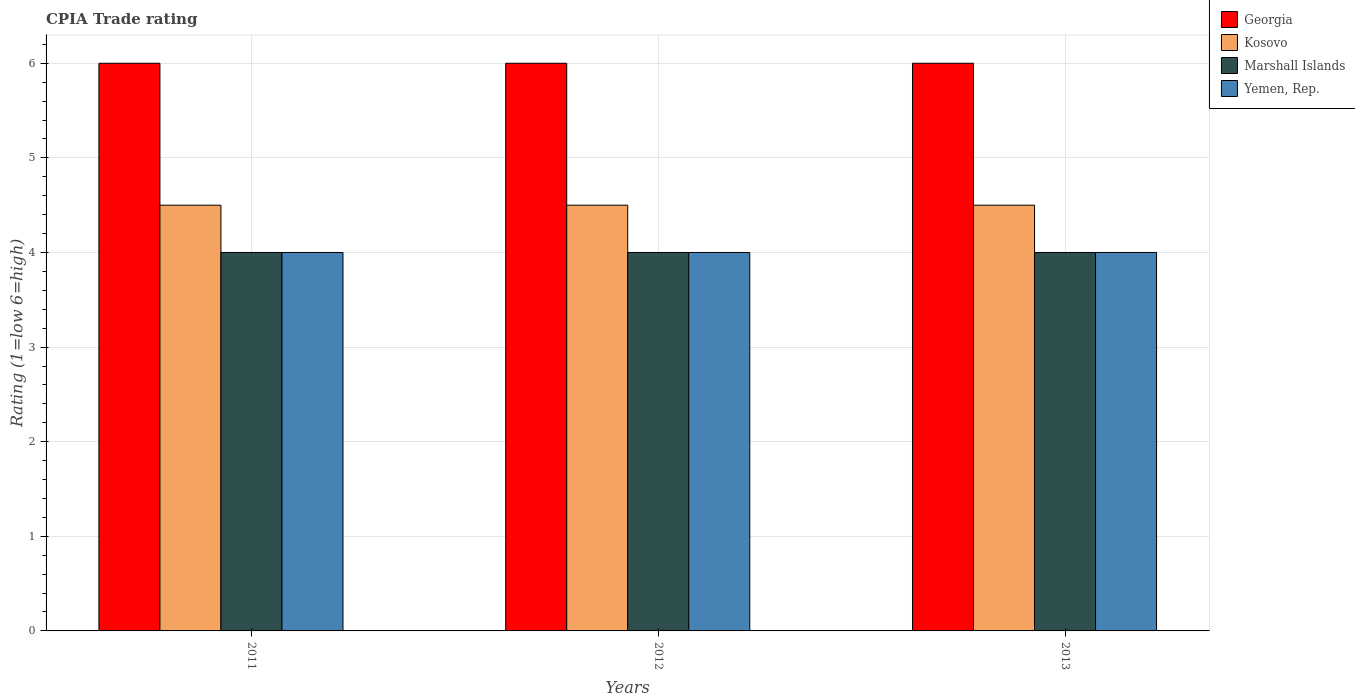Are the number of bars on each tick of the X-axis equal?
Your answer should be compact. Yes. How many bars are there on the 1st tick from the right?
Ensure brevity in your answer.  4. In how many cases, is the number of bars for a given year not equal to the number of legend labels?
Keep it short and to the point. 0. What is the CPIA rating in Marshall Islands in 2013?
Your answer should be compact. 4. Across all years, what is the minimum CPIA rating in Yemen, Rep.?
Your response must be concise. 4. In which year was the CPIA rating in Yemen, Rep. maximum?
Keep it short and to the point. 2011. In which year was the CPIA rating in Marshall Islands minimum?
Your answer should be very brief. 2011. What is the total CPIA rating in Yemen, Rep. in the graph?
Your answer should be compact. 12. In how many years, is the CPIA rating in Marshall Islands greater than 3.6?
Make the answer very short. 3. What is the ratio of the CPIA rating in Yemen, Rep. in 2012 to that in 2013?
Ensure brevity in your answer.  1. In how many years, is the CPIA rating in Georgia greater than the average CPIA rating in Georgia taken over all years?
Make the answer very short. 0. Is the sum of the CPIA rating in Marshall Islands in 2012 and 2013 greater than the maximum CPIA rating in Yemen, Rep. across all years?
Ensure brevity in your answer.  Yes. What does the 1st bar from the left in 2013 represents?
Give a very brief answer. Georgia. What does the 3rd bar from the right in 2011 represents?
Your answer should be very brief. Kosovo. How many bars are there?
Ensure brevity in your answer.  12. Does the graph contain any zero values?
Your response must be concise. No. Where does the legend appear in the graph?
Offer a terse response. Top right. How many legend labels are there?
Your answer should be compact. 4. How are the legend labels stacked?
Your answer should be very brief. Vertical. What is the title of the graph?
Provide a short and direct response. CPIA Trade rating. Does "United Kingdom" appear as one of the legend labels in the graph?
Offer a terse response. No. What is the label or title of the X-axis?
Provide a short and direct response. Years. What is the Rating (1=low 6=high) in Georgia in 2011?
Your response must be concise. 6. What is the Rating (1=low 6=high) of Georgia in 2012?
Ensure brevity in your answer.  6. What is the Rating (1=low 6=high) of Yemen, Rep. in 2012?
Your response must be concise. 4. What is the Rating (1=low 6=high) in Kosovo in 2013?
Ensure brevity in your answer.  4.5. What is the Rating (1=low 6=high) in Yemen, Rep. in 2013?
Provide a succinct answer. 4. Across all years, what is the maximum Rating (1=low 6=high) in Kosovo?
Provide a succinct answer. 4.5. Across all years, what is the minimum Rating (1=low 6=high) of Kosovo?
Offer a terse response. 4.5. Across all years, what is the minimum Rating (1=low 6=high) in Marshall Islands?
Give a very brief answer. 4. What is the difference between the Rating (1=low 6=high) in Georgia in 2011 and that in 2012?
Your response must be concise. 0. What is the difference between the Rating (1=low 6=high) of Kosovo in 2011 and that in 2013?
Keep it short and to the point. 0. What is the difference between the Rating (1=low 6=high) of Marshall Islands in 2011 and that in 2013?
Make the answer very short. 0. What is the difference between the Rating (1=low 6=high) of Kosovo in 2012 and that in 2013?
Provide a short and direct response. 0. What is the difference between the Rating (1=low 6=high) in Marshall Islands in 2012 and that in 2013?
Make the answer very short. 0. What is the difference between the Rating (1=low 6=high) in Georgia in 2011 and the Rating (1=low 6=high) in Kosovo in 2012?
Make the answer very short. 1.5. What is the difference between the Rating (1=low 6=high) of Georgia in 2011 and the Rating (1=low 6=high) of Yemen, Rep. in 2012?
Offer a very short reply. 2. What is the difference between the Rating (1=low 6=high) of Kosovo in 2011 and the Rating (1=low 6=high) of Marshall Islands in 2012?
Offer a very short reply. 0.5. What is the difference between the Rating (1=low 6=high) in Kosovo in 2011 and the Rating (1=low 6=high) in Yemen, Rep. in 2012?
Give a very brief answer. 0.5. What is the difference between the Rating (1=low 6=high) in Georgia in 2011 and the Rating (1=low 6=high) in Marshall Islands in 2013?
Provide a short and direct response. 2. What is the difference between the Rating (1=low 6=high) in Georgia in 2011 and the Rating (1=low 6=high) in Yemen, Rep. in 2013?
Give a very brief answer. 2. What is the difference between the Rating (1=low 6=high) in Kosovo in 2011 and the Rating (1=low 6=high) in Marshall Islands in 2013?
Make the answer very short. 0.5. What is the difference between the Rating (1=low 6=high) of Marshall Islands in 2011 and the Rating (1=low 6=high) of Yemen, Rep. in 2013?
Offer a very short reply. 0. What is the difference between the Rating (1=low 6=high) of Georgia in 2012 and the Rating (1=low 6=high) of Marshall Islands in 2013?
Your answer should be very brief. 2. What is the difference between the Rating (1=low 6=high) of Kosovo in 2012 and the Rating (1=low 6=high) of Marshall Islands in 2013?
Keep it short and to the point. 0.5. What is the difference between the Rating (1=low 6=high) of Marshall Islands in 2012 and the Rating (1=low 6=high) of Yemen, Rep. in 2013?
Ensure brevity in your answer.  0. What is the average Rating (1=low 6=high) of Marshall Islands per year?
Provide a succinct answer. 4. In the year 2011, what is the difference between the Rating (1=low 6=high) of Georgia and Rating (1=low 6=high) of Kosovo?
Your answer should be compact. 1.5. In the year 2011, what is the difference between the Rating (1=low 6=high) in Georgia and Rating (1=low 6=high) in Yemen, Rep.?
Ensure brevity in your answer.  2. In the year 2011, what is the difference between the Rating (1=low 6=high) of Kosovo and Rating (1=low 6=high) of Yemen, Rep.?
Ensure brevity in your answer.  0.5. In the year 2012, what is the difference between the Rating (1=low 6=high) in Georgia and Rating (1=low 6=high) in Yemen, Rep.?
Ensure brevity in your answer.  2. In the year 2012, what is the difference between the Rating (1=low 6=high) of Kosovo and Rating (1=low 6=high) of Yemen, Rep.?
Your answer should be compact. 0.5. In the year 2013, what is the difference between the Rating (1=low 6=high) of Georgia and Rating (1=low 6=high) of Yemen, Rep.?
Offer a terse response. 2. In the year 2013, what is the difference between the Rating (1=low 6=high) in Kosovo and Rating (1=low 6=high) in Marshall Islands?
Provide a short and direct response. 0.5. In the year 2013, what is the difference between the Rating (1=low 6=high) in Marshall Islands and Rating (1=low 6=high) in Yemen, Rep.?
Your answer should be very brief. 0. What is the ratio of the Rating (1=low 6=high) in Kosovo in 2011 to that in 2012?
Offer a terse response. 1. What is the ratio of the Rating (1=low 6=high) of Marshall Islands in 2011 to that in 2012?
Give a very brief answer. 1. What is the ratio of the Rating (1=low 6=high) in Georgia in 2011 to that in 2013?
Provide a short and direct response. 1. What is the ratio of the Rating (1=low 6=high) of Kosovo in 2011 to that in 2013?
Your answer should be compact. 1. What is the ratio of the Rating (1=low 6=high) of Yemen, Rep. in 2011 to that in 2013?
Keep it short and to the point. 1. What is the ratio of the Rating (1=low 6=high) of Georgia in 2012 to that in 2013?
Your answer should be compact. 1. What is the ratio of the Rating (1=low 6=high) in Kosovo in 2012 to that in 2013?
Your response must be concise. 1. What is the difference between the highest and the second highest Rating (1=low 6=high) of Yemen, Rep.?
Keep it short and to the point. 0. What is the difference between the highest and the lowest Rating (1=low 6=high) of Kosovo?
Offer a very short reply. 0. What is the difference between the highest and the lowest Rating (1=low 6=high) of Marshall Islands?
Offer a very short reply. 0. What is the difference between the highest and the lowest Rating (1=low 6=high) of Yemen, Rep.?
Ensure brevity in your answer.  0. 